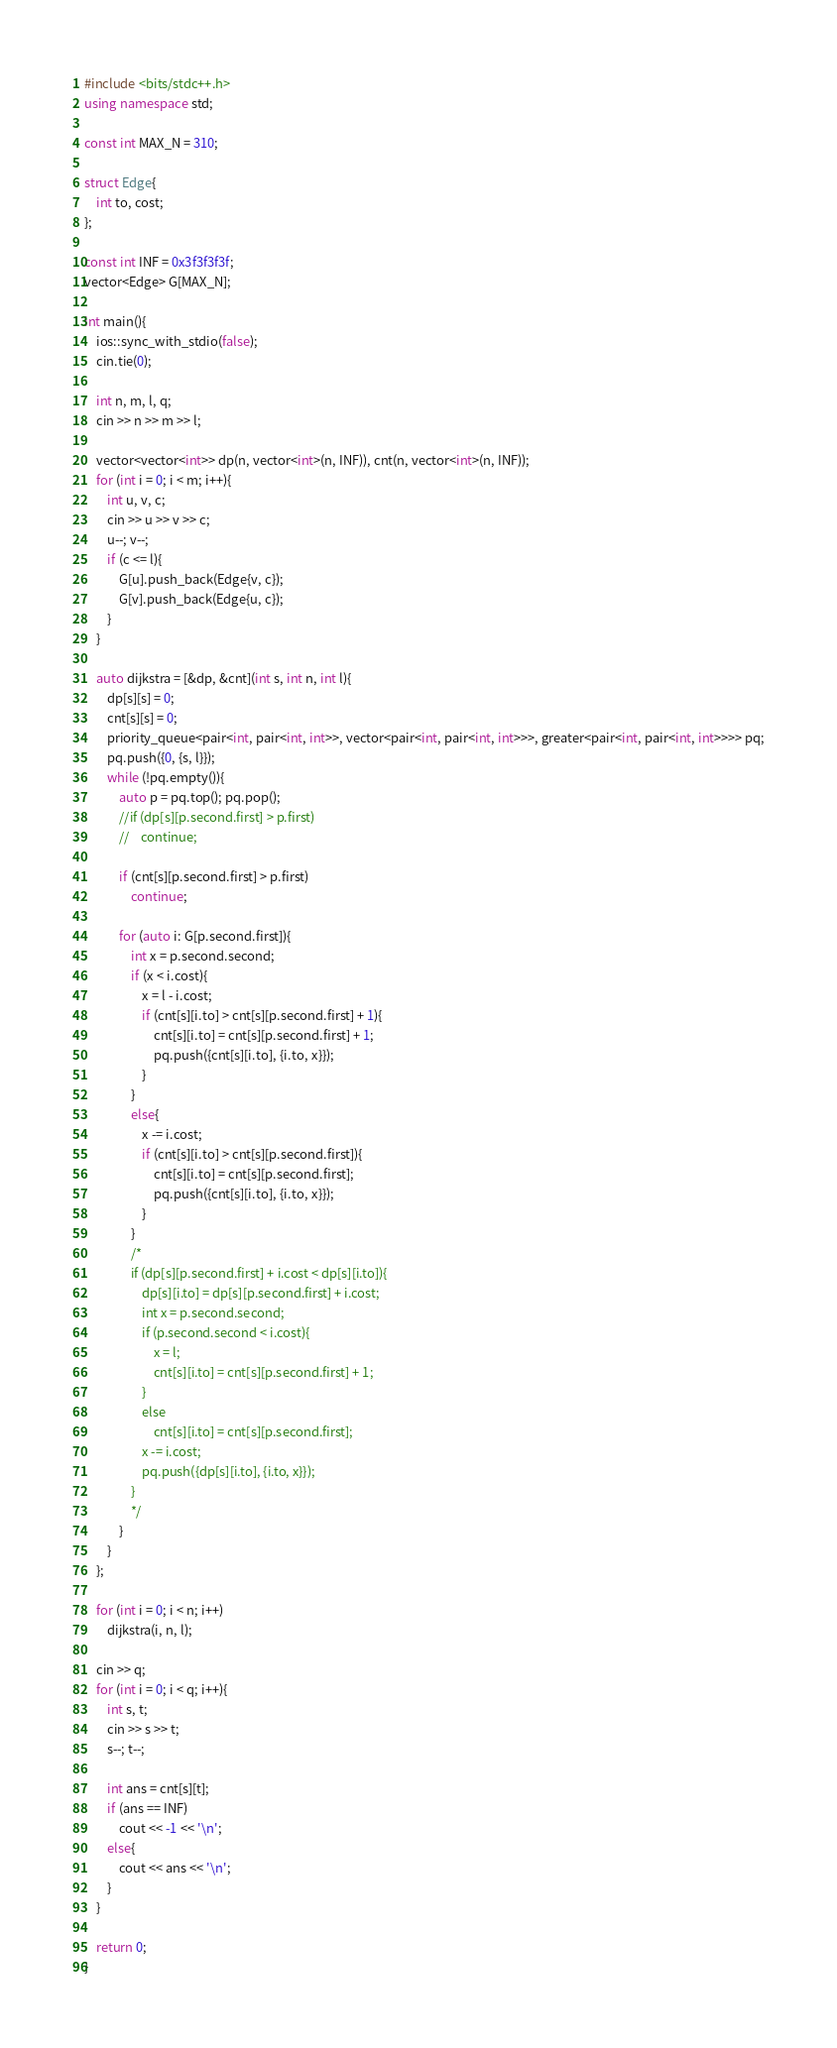Convert code to text. <code><loc_0><loc_0><loc_500><loc_500><_C++_>#include <bits/stdc++.h>
using namespace std;

const int MAX_N = 310;

struct Edge{
    int to, cost;
};

const int INF = 0x3f3f3f3f;
vector<Edge> G[MAX_N];

int main(){
    ios::sync_with_stdio(false);
    cin.tie(0);
    
    int n, m, l, q;
    cin >> n >> m >> l;

    vector<vector<int>> dp(n, vector<int>(n, INF)), cnt(n, vector<int>(n, INF));
    for (int i = 0; i < m; i++){
        int u, v, c;
        cin >> u >> v >> c;
        u--; v--;
        if (c <= l){
            G[u].push_back(Edge{v, c});
            G[v].push_back(Edge{u, c});
        }
    }
    
    auto dijkstra = [&dp, &cnt](int s, int n, int l){
        dp[s][s] = 0;
        cnt[s][s] = 0;
        priority_queue<pair<int, pair<int, int>>, vector<pair<int, pair<int, int>>>, greater<pair<int, pair<int, int>>>> pq;
        pq.push({0, {s, l}});
        while (!pq.empty()){
            auto p = pq.top(); pq.pop();
            //if (dp[s][p.second.first] > p.first)
            //    continue;
            
            if (cnt[s][p.second.first] > p.first)
                continue;

            for (auto i: G[p.second.first]){
                int x = p.second.second;
                if (x < i.cost){
                    x = l - i.cost;
                    if (cnt[s][i.to] > cnt[s][p.second.first] + 1){
                        cnt[s][i.to] = cnt[s][p.second.first] + 1;
                        pq.push({cnt[s][i.to], {i.to, x}});
                    }
                }
                else{
                    x -= i.cost;
                    if (cnt[s][i.to] > cnt[s][p.second.first]){
                        cnt[s][i.to] = cnt[s][p.second.first];
                        pq.push({cnt[s][i.to], {i.to, x}});
                    }
                }
                /*
                if (dp[s][p.second.first] + i.cost < dp[s][i.to]){
                    dp[s][i.to] = dp[s][p.second.first] + i.cost;
                    int x = p.second.second;
                    if (p.second.second < i.cost){
                        x = l;
                        cnt[s][i.to] = cnt[s][p.second.first] + 1;
                    }
                    else
                        cnt[s][i.to] = cnt[s][p.second.first];
                    x -= i.cost;
                    pq.push({dp[s][i.to], {i.to, x}});
                }
                */
            }
        }
    };

    for (int i = 0; i < n; i++)
        dijkstra(i, n, l);

    cin >> q;
    for (int i = 0; i < q; i++){
        int s, t;
        cin >> s >> t;
        s--; t--;

        int ans = cnt[s][t];
        if (ans == INF)
            cout << -1 << '\n';
        else{
            cout << ans << '\n';
        }
    }

    return 0;
}
</code> 